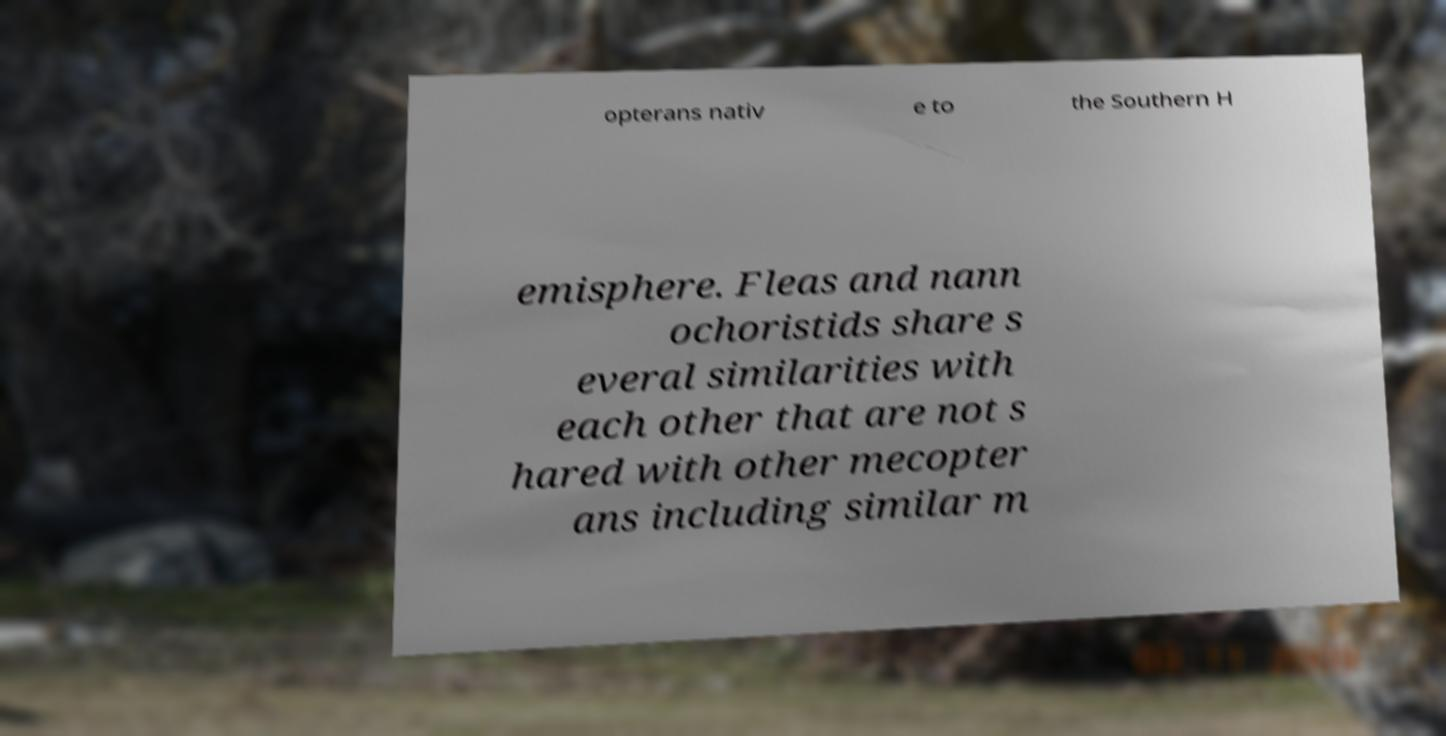Could you assist in decoding the text presented in this image and type it out clearly? opterans nativ e to the Southern H emisphere. Fleas and nann ochoristids share s everal similarities with each other that are not s hared with other mecopter ans including similar m 